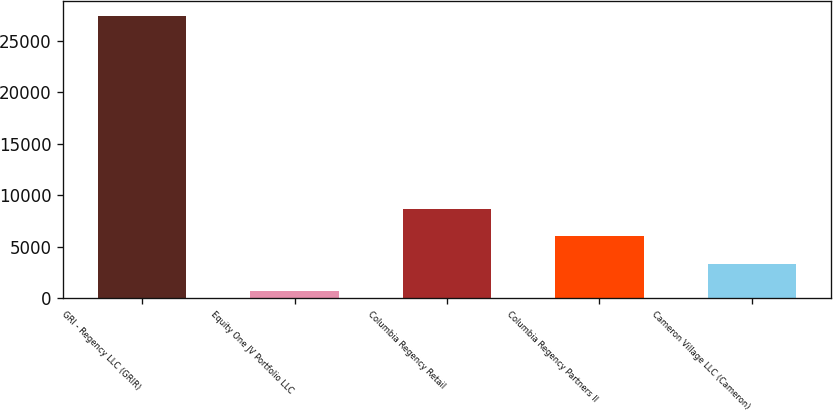<chart> <loc_0><loc_0><loc_500><loc_500><bar_chart><fcel>GRI - Regency LLC (GRIR)<fcel>Equity One JV Portfolio LLC<fcel>Columbia Regency Retail<fcel>Columbia Regency Partners II<fcel>Cameron Village LLC (Cameron)<nl><fcel>27440<fcel>686<fcel>8712.2<fcel>6036.8<fcel>3361.4<nl></chart> 